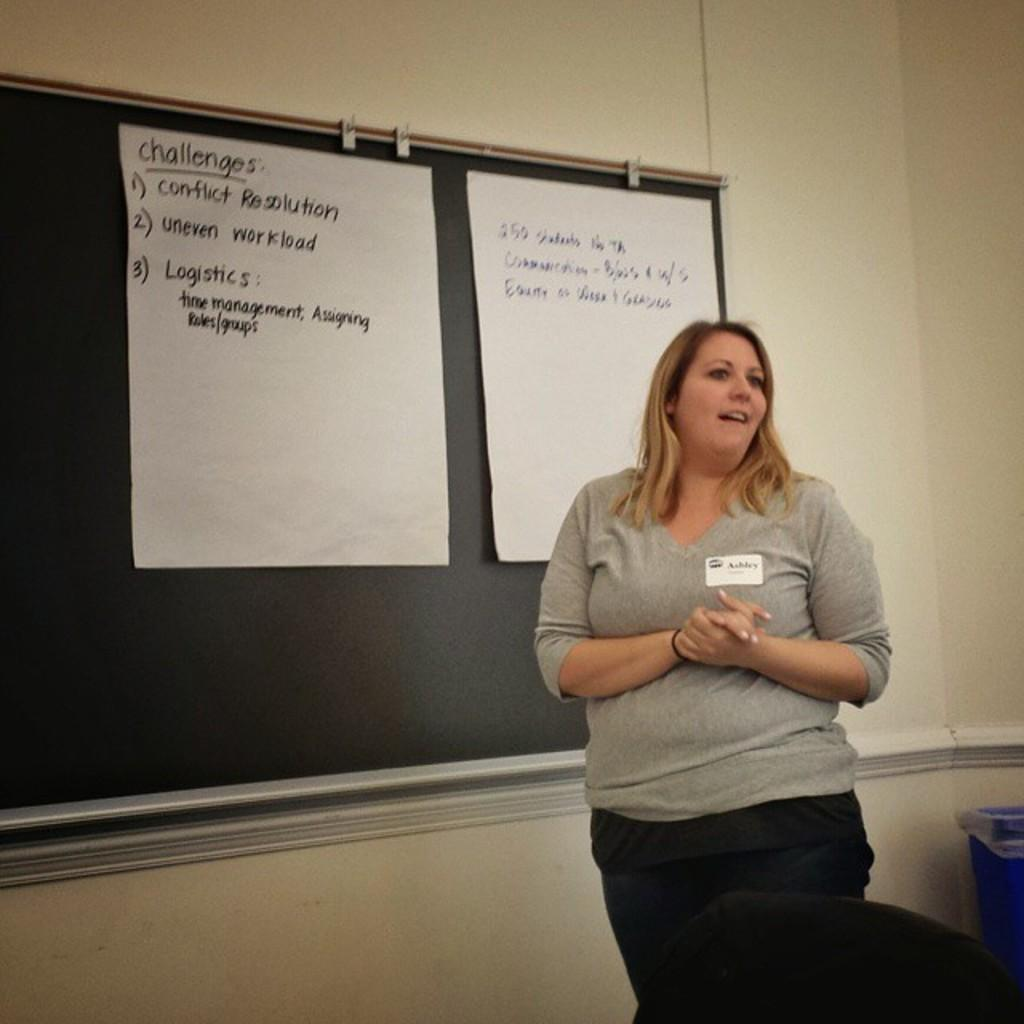Who is present in the image? There is a woman standing in the image. What object can be seen in the image besides the woman? There is a board in the image. What is on the board? There are two papers on the board. What is the board attached to? The board is attached to a cream-colored wall. What type of bead is hanging from the woman's neck in the image? There is no bead visible around the woman's neck in the image. What kind of cheese is placed on the board in the image? There is no cheese present on the board in the image; it has two papers instead. 